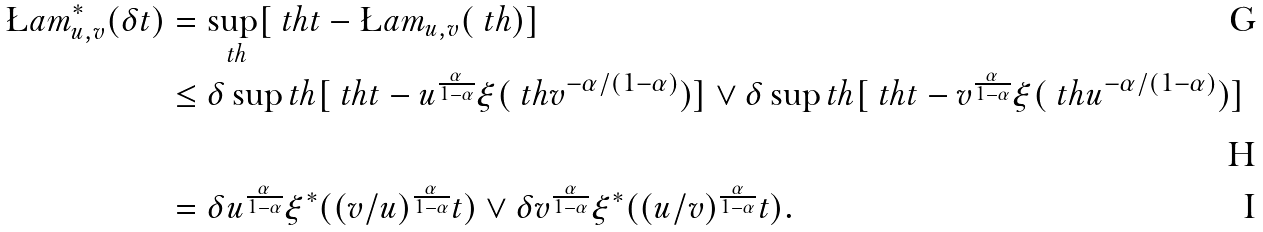Convert formula to latex. <formula><loc_0><loc_0><loc_500><loc_500>\L a m ^ { * } _ { u , v } ( \delta t ) & = \sup _ { \ t h } [ \ t h t - \L a m _ { u , v } ( \ t h ) ] \\ & \leq \delta \sup _ { \ } t h [ \ t h t - u ^ { \frac { \alpha } { 1 - \alpha } } \xi ( \ t h v ^ { - \alpha / ( 1 - \alpha ) } ) ] \vee \delta \sup _ { \ } t h [ \ t h t - v ^ { \frac { \alpha } { 1 - \alpha } } \xi ( \ t h u ^ { - \alpha / ( 1 - \alpha ) } ) ] \\ & = \delta u ^ { \frac { \alpha } { 1 - \alpha } } \xi ^ { * } ( ( v / u ) ^ { \frac { \alpha } { 1 - \alpha } } t ) \vee \delta v ^ { \frac { \alpha } { 1 - \alpha } } \xi ^ { * } ( ( u / v ) ^ { \frac { \alpha } { 1 - \alpha } } t ) .</formula> 